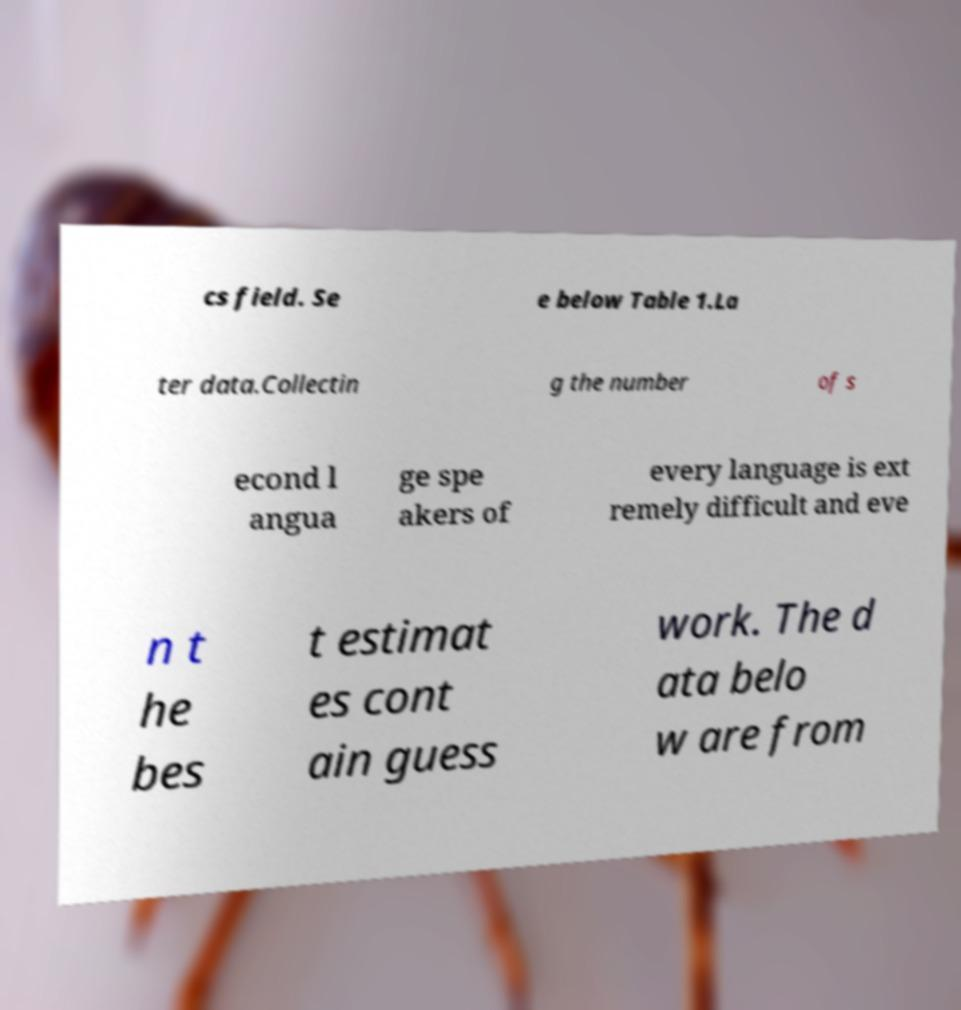Could you extract and type out the text from this image? cs field. Se e below Table 1.La ter data.Collectin g the number of s econd l angua ge spe akers of every language is ext remely difficult and eve n t he bes t estimat es cont ain guess work. The d ata belo w are from 